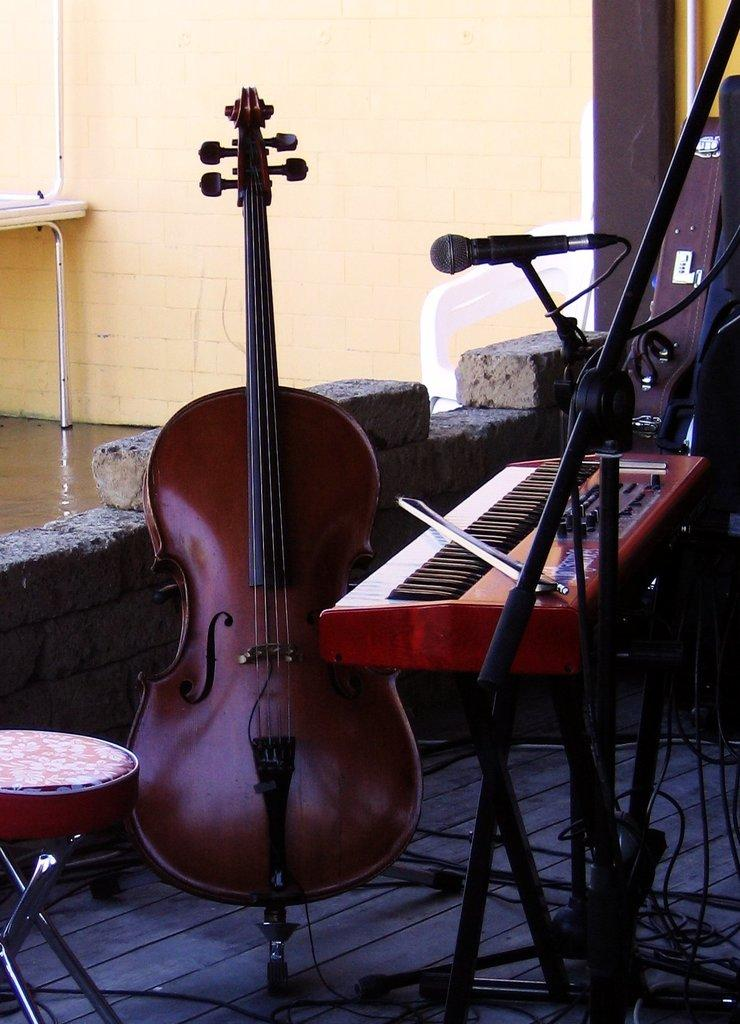What objects in the image are related to music? There are musical instruments, stands, and a microphone in the image. What type of furniture is present in the image? There is a stool in the image. What can be seen connecting the musical instruments and stands? There are wires in the image. What is the color of the wall in the image? The wall in the image is cream-colored. What type of invention is being demonstrated in the image? There is no invention being demonstrated in the image; it features musical instruments and related equipment. What type of grain is visible in the image? There is no grain visible in the image. What type of tin is being used to hold the musical instruments in the image? There is no tin present in the image; the musical instruments are placed on stands and connected by wires. 